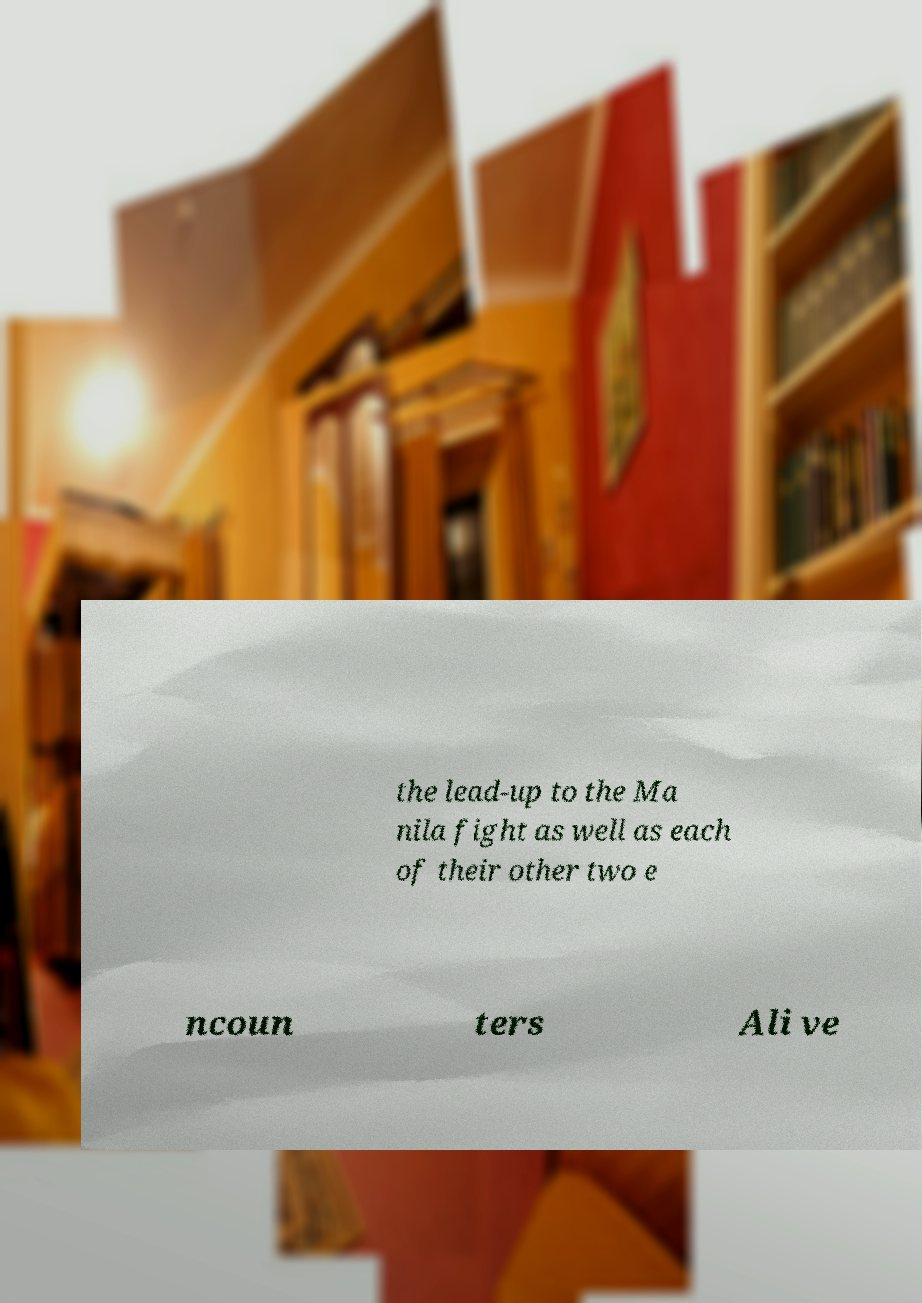Can you read and provide the text displayed in the image?This photo seems to have some interesting text. Can you extract and type it out for me? the lead-up to the Ma nila fight as well as each of their other two e ncoun ters Ali ve 